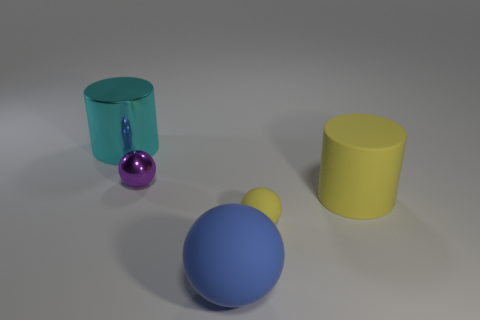Add 1 metal spheres. How many objects exist? 6 Subtract all cylinders. How many objects are left? 3 Subtract all matte objects. Subtract all yellow cylinders. How many objects are left? 1 Add 3 tiny matte things. How many tiny matte things are left? 4 Add 3 tiny green things. How many tiny green things exist? 3 Subtract 0 red cylinders. How many objects are left? 5 